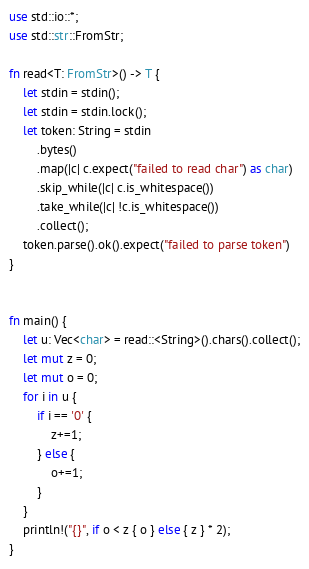Convert code to text. <code><loc_0><loc_0><loc_500><loc_500><_Rust_>use std::io::*;
use std::str::FromStr;

fn read<T: FromStr>() -> T {
    let stdin = stdin();
    let stdin = stdin.lock();
    let token: String = stdin
        .bytes()
        .map(|c| c.expect("failed to read char") as char)
        .skip_while(|c| c.is_whitespace())
        .take_while(|c| !c.is_whitespace())
        .collect();
    token.parse().ok().expect("failed to parse token")
}


fn main() {
    let u: Vec<char> = read::<String>().chars().collect();
    let mut z = 0;
    let mut o = 0;
    for i in u {
        if i == '0' {
            z+=1;
        } else {
            o+=1;
        }
    }
    println!("{}", if o < z { o } else { z } * 2);
}</code> 